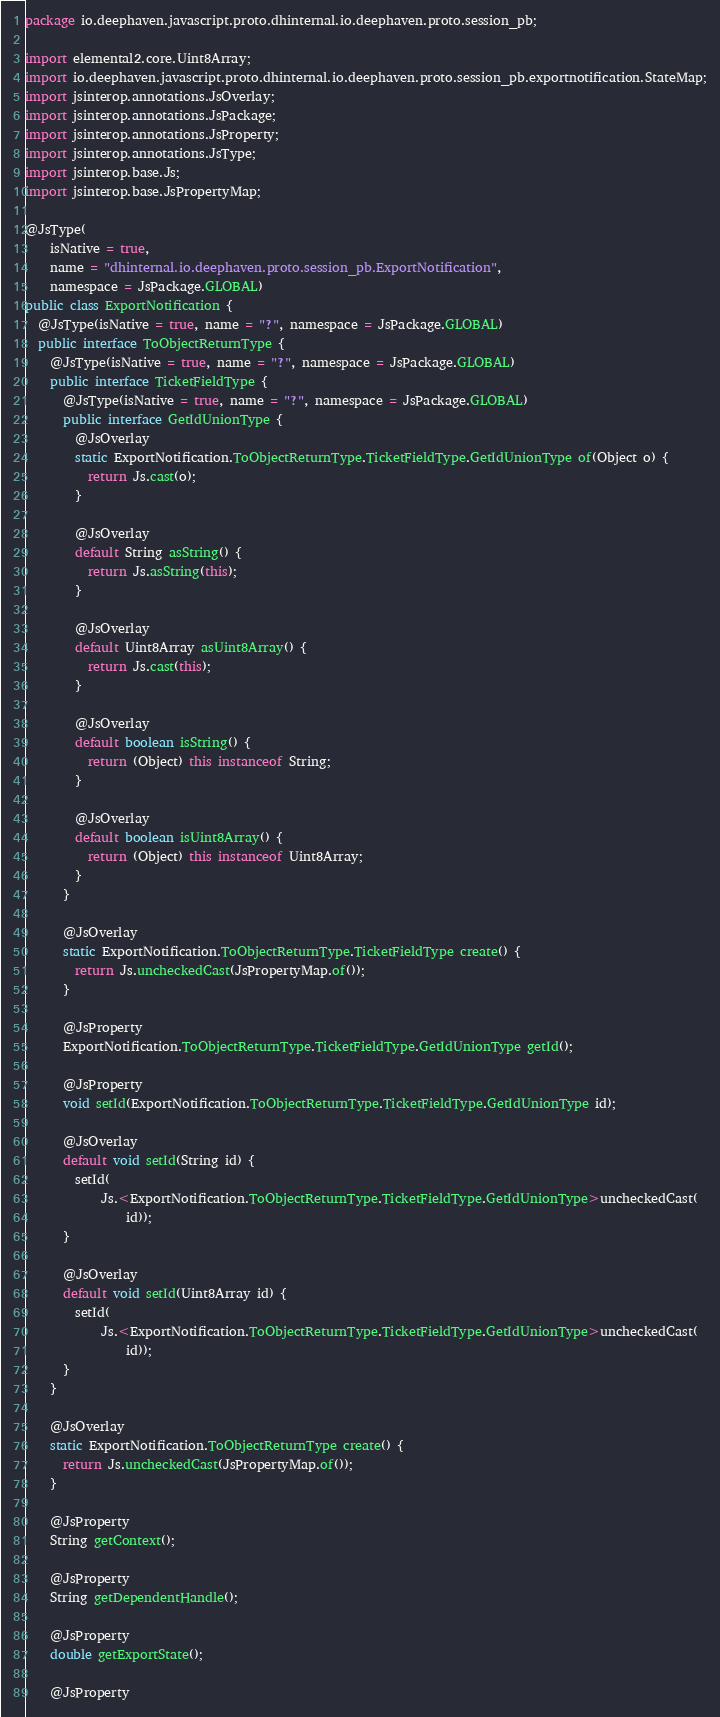Convert code to text. <code><loc_0><loc_0><loc_500><loc_500><_Java_>package io.deephaven.javascript.proto.dhinternal.io.deephaven.proto.session_pb;

import elemental2.core.Uint8Array;
import io.deephaven.javascript.proto.dhinternal.io.deephaven.proto.session_pb.exportnotification.StateMap;
import jsinterop.annotations.JsOverlay;
import jsinterop.annotations.JsPackage;
import jsinterop.annotations.JsProperty;
import jsinterop.annotations.JsType;
import jsinterop.base.Js;
import jsinterop.base.JsPropertyMap;

@JsType(
    isNative = true,
    name = "dhinternal.io.deephaven.proto.session_pb.ExportNotification",
    namespace = JsPackage.GLOBAL)
public class ExportNotification {
  @JsType(isNative = true, name = "?", namespace = JsPackage.GLOBAL)
  public interface ToObjectReturnType {
    @JsType(isNative = true, name = "?", namespace = JsPackage.GLOBAL)
    public interface TicketFieldType {
      @JsType(isNative = true, name = "?", namespace = JsPackage.GLOBAL)
      public interface GetIdUnionType {
        @JsOverlay
        static ExportNotification.ToObjectReturnType.TicketFieldType.GetIdUnionType of(Object o) {
          return Js.cast(o);
        }

        @JsOverlay
        default String asString() {
          return Js.asString(this);
        }

        @JsOverlay
        default Uint8Array asUint8Array() {
          return Js.cast(this);
        }

        @JsOverlay
        default boolean isString() {
          return (Object) this instanceof String;
        }

        @JsOverlay
        default boolean isUint8Array() {
          return (Object) this instanceof Uint8Array;
        }
      }

      @JsOverlay
      static ExportNotification.ToObjectReturnType.TicketFieldType create() {
        return Js.uncheckedCast(JsPropertyMap.of());
      }

      @JsProperty
      ExportNotification.ToObjectReturnType.TicketFieldType.GetIdUnionType getId();

      @JsProperty
      void setId(ExportNotification.ToObjectReturnType.TicketFieldType.GetIdUnionType id);

      @JsOverlay
      default void setId(String id) {
        setId(
            Js.<ExportNotification.ToObjectReturnType.TicketFieldType.GetIdUnionType>uncheckedCast(
                id));
      }

      @JsOverlay
      default void setId(Uint8Array id) {
        setId(
            Js.<ExportNotification.ToObjectReturnType.TicketFieldType.GetIdUnionType>uncheckedCast(
                id));
      }
    }

    @JsOverlay
    static ExportNotification.ToObjectReturnType create() {
      return Js.uncheckedCast(JsPropertyMap.of());
    }

    @JsProperty
    String getContext();

    @JsProperty
    String getDependentHandle();

    @JsProperty
    double getExportState();

    @JsProperty</code> 